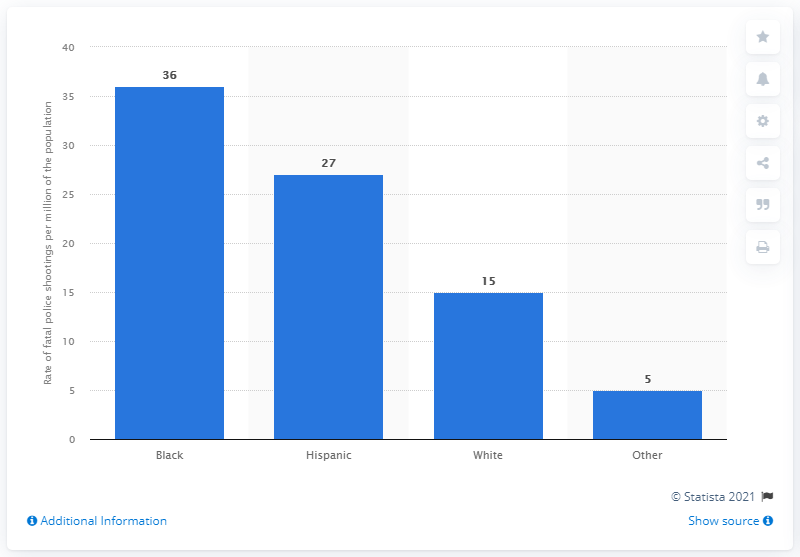Indicate a few pertinent items in this graphic. Between June 2021 and June 2021, there were 15 fatal police shootings. In the period between 2015 and 2021, the rate of fatal police shootings per million of the population was approximately 36. 